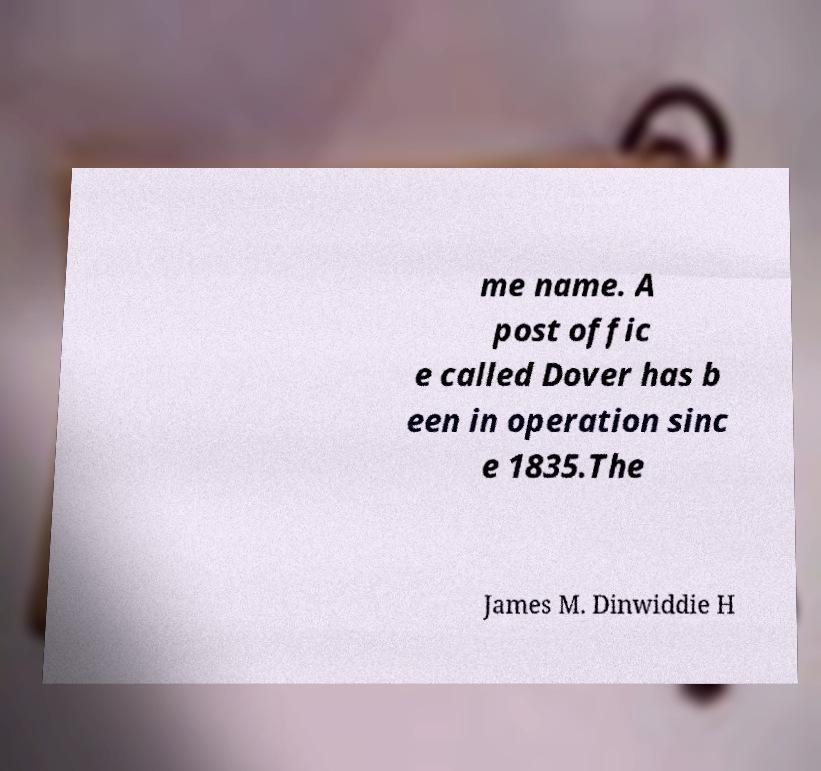Could you extract and type out the text from this image? me name. A post offic e called Dover has b een in operation sinc e 1835.The James M. Dinwiddie H 